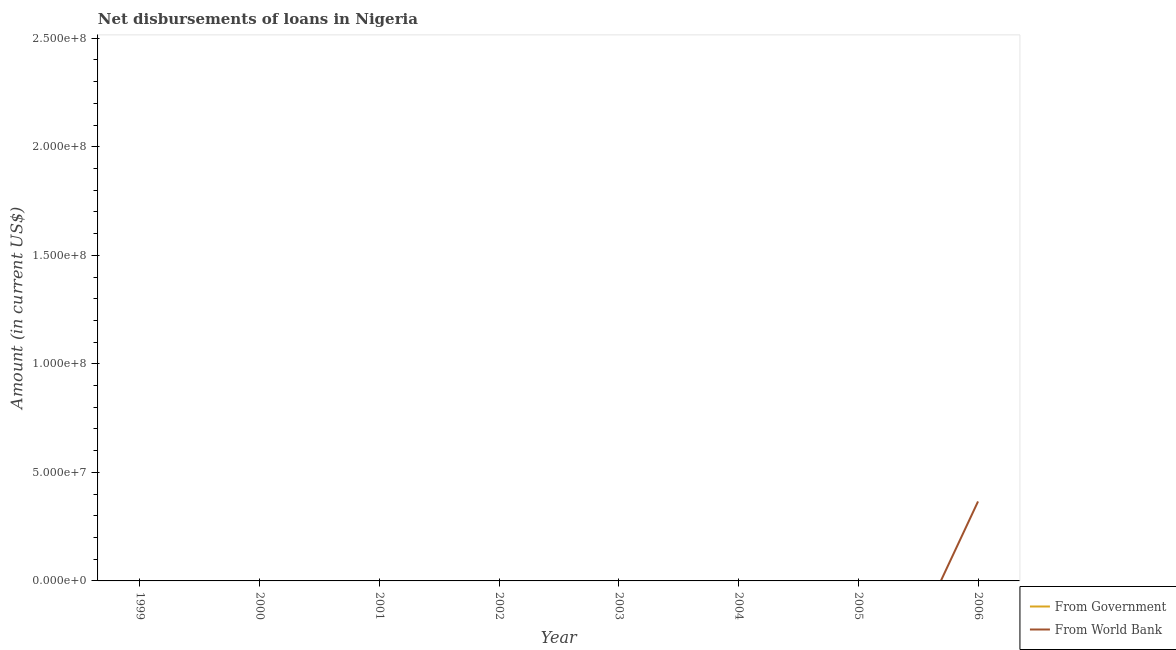What is the net disbursements of loan from world bank in 2002?
Give a very brief answer. 0. Across all years, what is the maximum net disbursements of loan from world bank?
Your answer should be compact. 3.66e+07. In which year was the net disbursements of loan from world bank maximum?
Your answer should be very brief. 2006. What is the average net disbursements of loan from world bank per year?
Make the answer very short. 4.58e+06. In how many years, is the net disbursements of loan from government greater than 100000000 US$?
Offer a terse response. 0. What is the difference between the highest and the lowest net disbursements of loan from world bank?
Make the answer very short. 3.66e+07. Is the net disbursements of loan from government strictly greater than the net disbursements of loan from world bank over the years?
Give a very brief answer. No. Is the net disbursements of loan from world bank strictly less than the net disbursements of loan from government over the years?
Ensure brevity in your answer.  No. What is the difference between two consecutive major ticks on the Y-axis?
Give a very brief answer. 5.00e+07. Does the graph contain any zero values?
Provide a short and direct response. Yes. Does the graph contain grids?
Ensure brevity in your answer.  No. Where does the legend appear in the graph?
Offer a very short reply. Bottom right. How many legend labels are there?
Provide a succinct answer. 2. How are the legend labels stacked?
Provide a succinct answer. Vertical. What is the title of the graph?
Offer a terse response. Net disbursements of loans in Nigeria. What is the label or title of the Y-axis?
Offer a terse response. Amount (in current US$). What is the Amount (in current US$) in From Government in 1999?
Your answer should be very brief. 0. What is the Amount (in current US$) in From World Bank in 2001?
Give a very brief answer. 0. What is the Amount (in current US$) of From Government in 2002?
Offer a very short reply. 0. What is the Amount (in current US$) in From World Bank in 2004?
Give a very brief answer. 0. What is the Amount (in current US$) in From Government in 2005?
Provide a short and direct response. 0. What is the Amount (in current US$) of From World Bank in 2005?
Offer a very short reply. 0. What is the Amount (in current US$) in From World Bank in 2006?
Provide a short and direct response. 3.66e+07. Across all years, what is the maximum Amount (in current US$) in From World Bank?
Offer a very short reply. 3.66e+07. What is the total Amount (in current US$) in From Government in the graph?
Provide a succinct answer. 0. What is the total Amount (in current US$) in From World Bank in the graph?
Give a very brief answer. 3.66e+07. What is the average Amount (in current US$) of From Government per year?
Ensure brevity in your answer.  0. What is the average Amount (in current US$) of From World Bank per year?
Offer a terse response. 4.58e+06. What is the difference between the highest and the lowest Amount (in current US$) of From World Bank?
Offer a very short reply. 3.66e+07. 